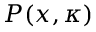<formula> <loc_0><loc_0><loc_500><loc_500>P ( x , \kappa )</formula> 